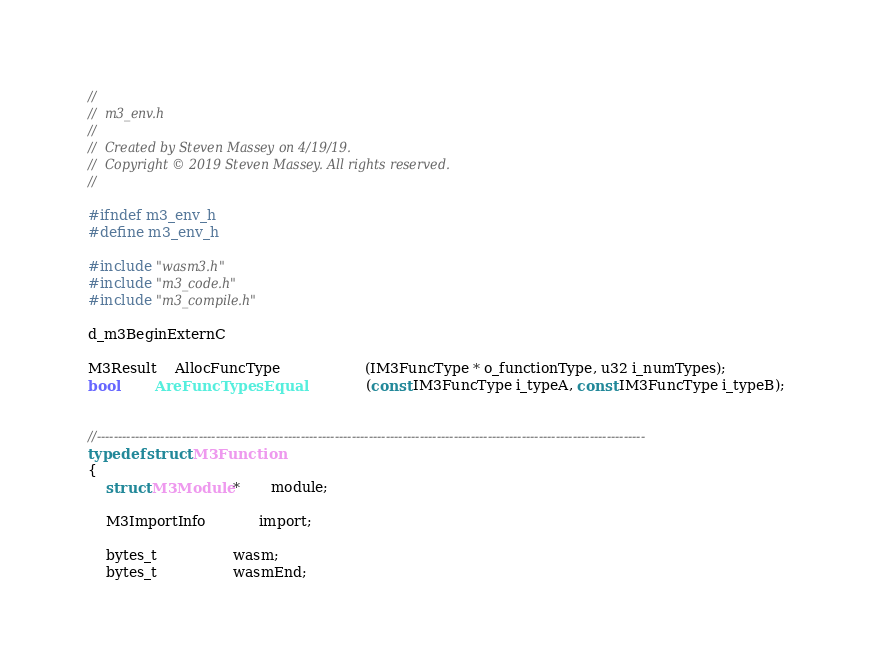<code> <loc_0><loc_0><loc_500><loc_500><_C_>//
//  m3_env.h
//
//  Created by Steven Massey on 4/19/19.
//  Copyright © 2019 Steven Massey. All rights reserved.
//

#ifndef m3_env_h
#define m3_env_h

#include "wasm3.h"
#include "m3_code.h"
#include "m3_compile.h"

d_m3BeginExternC

M3Result    AllocFuncType                   (IM3FuncType * o_functionType, u32 i_numTypes);
bool        AreFuncTypesEqual               (const IM3FuncType i_typeA, const IM3FuncType i_typeB);


//---------------------------------------------------------------------------------------------------------------------------------
typedef struct M3Function
{
    struct M3Module *       module;

    M3ImportInfo            import;

    bytes_t                 wasm;
    bytes_t                 wasmEnd;
</code> 